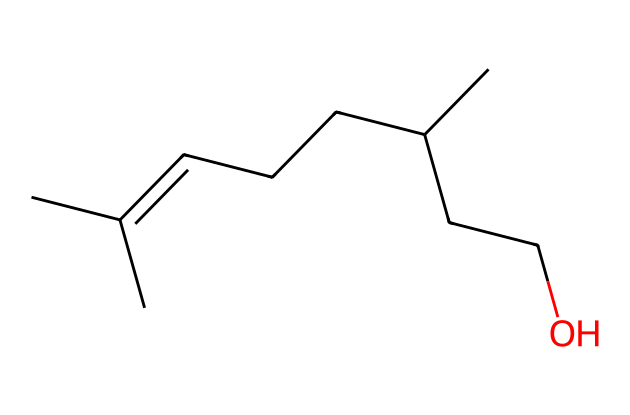What is the total number of carbon atoms in this compound? The provided SMILES representation shows that there are six carbon atoms in the main chain and two additional carbon atoms as branches, totaling eight carbon atoms.
Answer: eight How many oxygen atoms does the chemical contain? By analyzing the SMILES representation, there is one "O" towards the end, indicating there is a single oxygen atom present in this compound.
Answer: one What type of isomerism is indicated by the presence of double bonds in the compound? The presence of double bonds in the compound means it can exhibit geometric isomerism depending on the orientation of the substituents around the double bond.
Answer: geometric How does the branching in this compound affect its boiling point compared to its straight-chain isomers? The presence of branching generally lowers the boiling point compared to straight-chain isomers due to decreased surface area and molecular interactions, making it easier for the molecules to escape into the vapor phase.
Answer: lowers Which geometric isomer could this compound potentially form if a double bond is present? This compound could potentially form a cis and trans isomer if a double bond exists between any two carbons with different substituents, allowing for two distinct spatial arrangements.
Answer: cis and trans What functional group is present in this compound? The "O" at the end of the SMILES indicates the presence of an alcohol functional group, specifically a hydroxyl (-OH) group, which is characteristic of alcohols.
Answer: alcohol Which configuration around the double bond is more stable: cis or trans? Generally, trans isomers are more stable due to less steric hindrance between large groups on opposite sides, leading to a more stable arrangement.
Answer: trans 